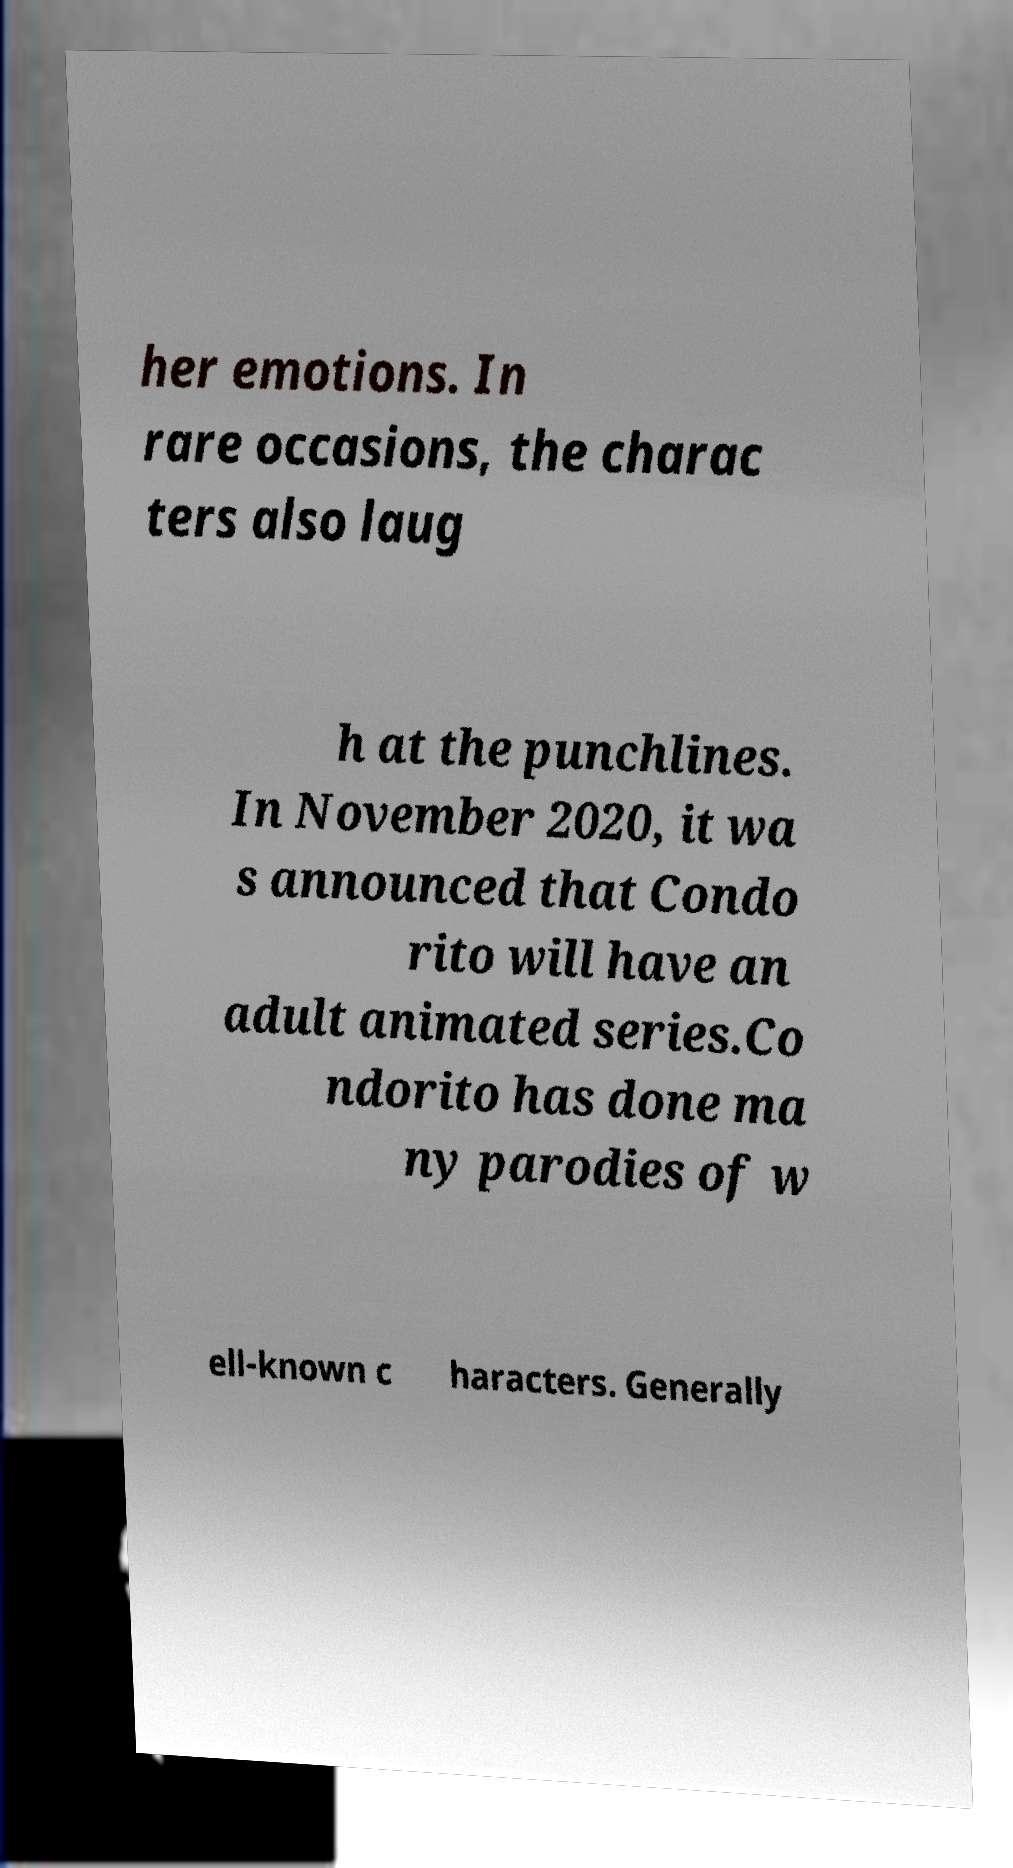Please identify and transcribe the text found in this image. her emotions. In rare occasions, the charac ters also laug h at the punchlines. In November 2020, it wa s announced that Condo rito will have an adult animated series.Co ndorito has done ma ny parodies of w ell-known c haracters. Generally 